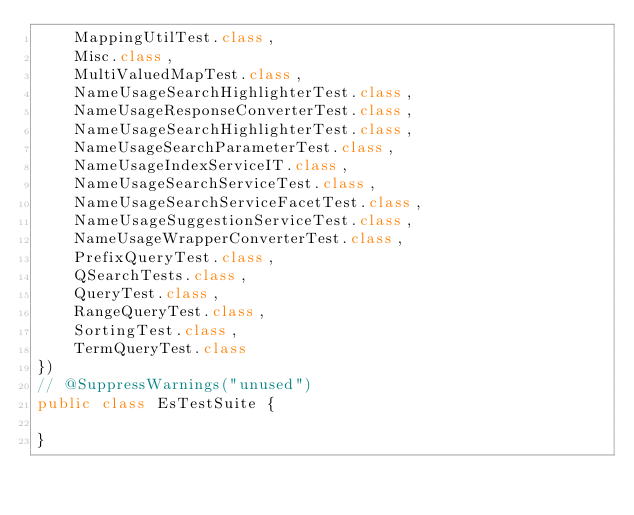Convert code to text. <code><loc_0><loc_0><loc_500><loc_500><_Java_>    MappingUtilTest.class,
    Misc.class,
    MultiValuedMapTest.class,
    NameUsageSearchHighlighterTest.class,
    NameUsageResponseConverterTest.class,
    NameUsageSearchHighlighterTest.class,
    NameUsageSearchParameterTest.class,
    NameUsageIndexServiceIT.class,
    NameUsageSearchServiceTest.class,
    NameUsageSearchServiceFacetTest.class,
    NameUsageSuggestionServiceTest.class,
    NameUsageWrapperConverterTest.class,
    PrefixQueryTest.class,
    QSearchTests.class,
    QueryTest.class,
    RangeQueryTest.class,
    SortingTest.class,
    TermQueryTest.class
})
// @SuppressWarnings("unused")
public class EsTestSuite {

}
</code> 